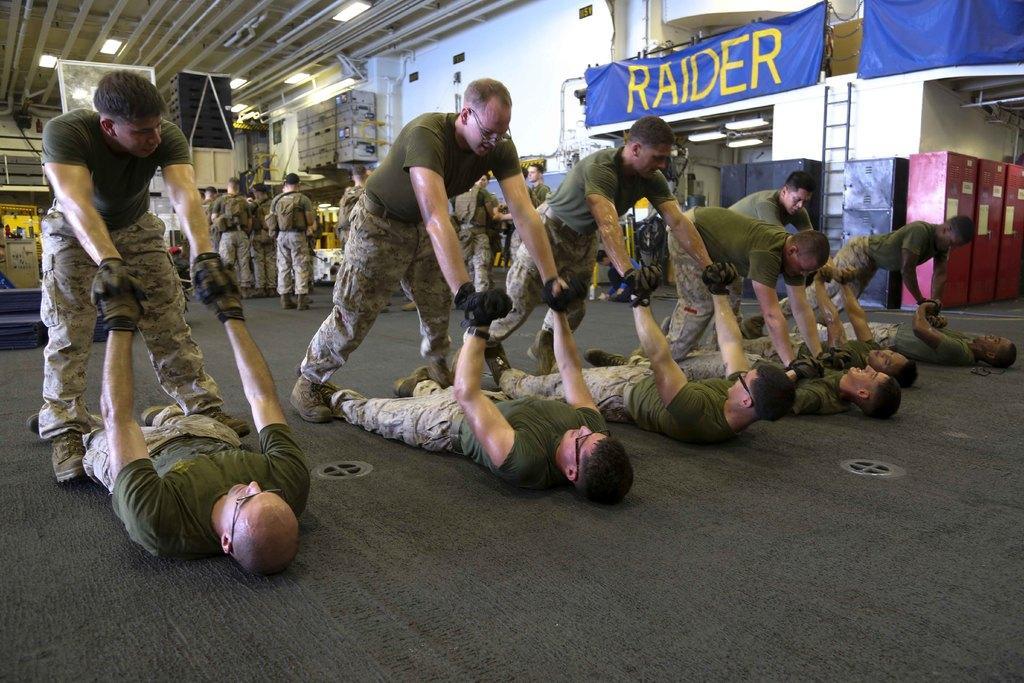Please provide a concise description of this image. In the picture I can see many people among them few are standing and few are lying on the floor and a few are standing in the background. They are all wearing grey color T-shirts, pants, gloves and shoes. Here I can see blue color banners, ladder, some objects and ceiling lights in the background. 